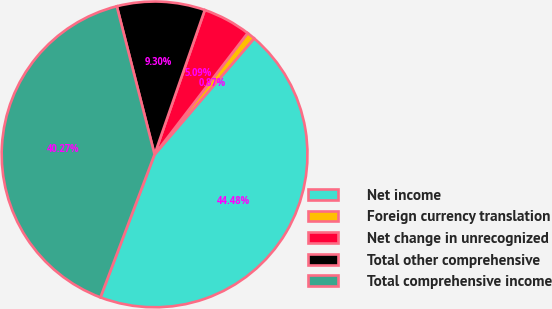<chart> <loc_0><loc_0><loc_500><loc_500><pie_chart><fcel>Net income<fcel>Foreign currency translation<fcel>Net change in unrecognized<fcel>Total other comprehensive<fcel>Total comprehensive income<nl><fcel>44.48%<fcel>0.87%<fcel>5.09%<fcel>9.3%<fcel>40.27%<nl></chart> 